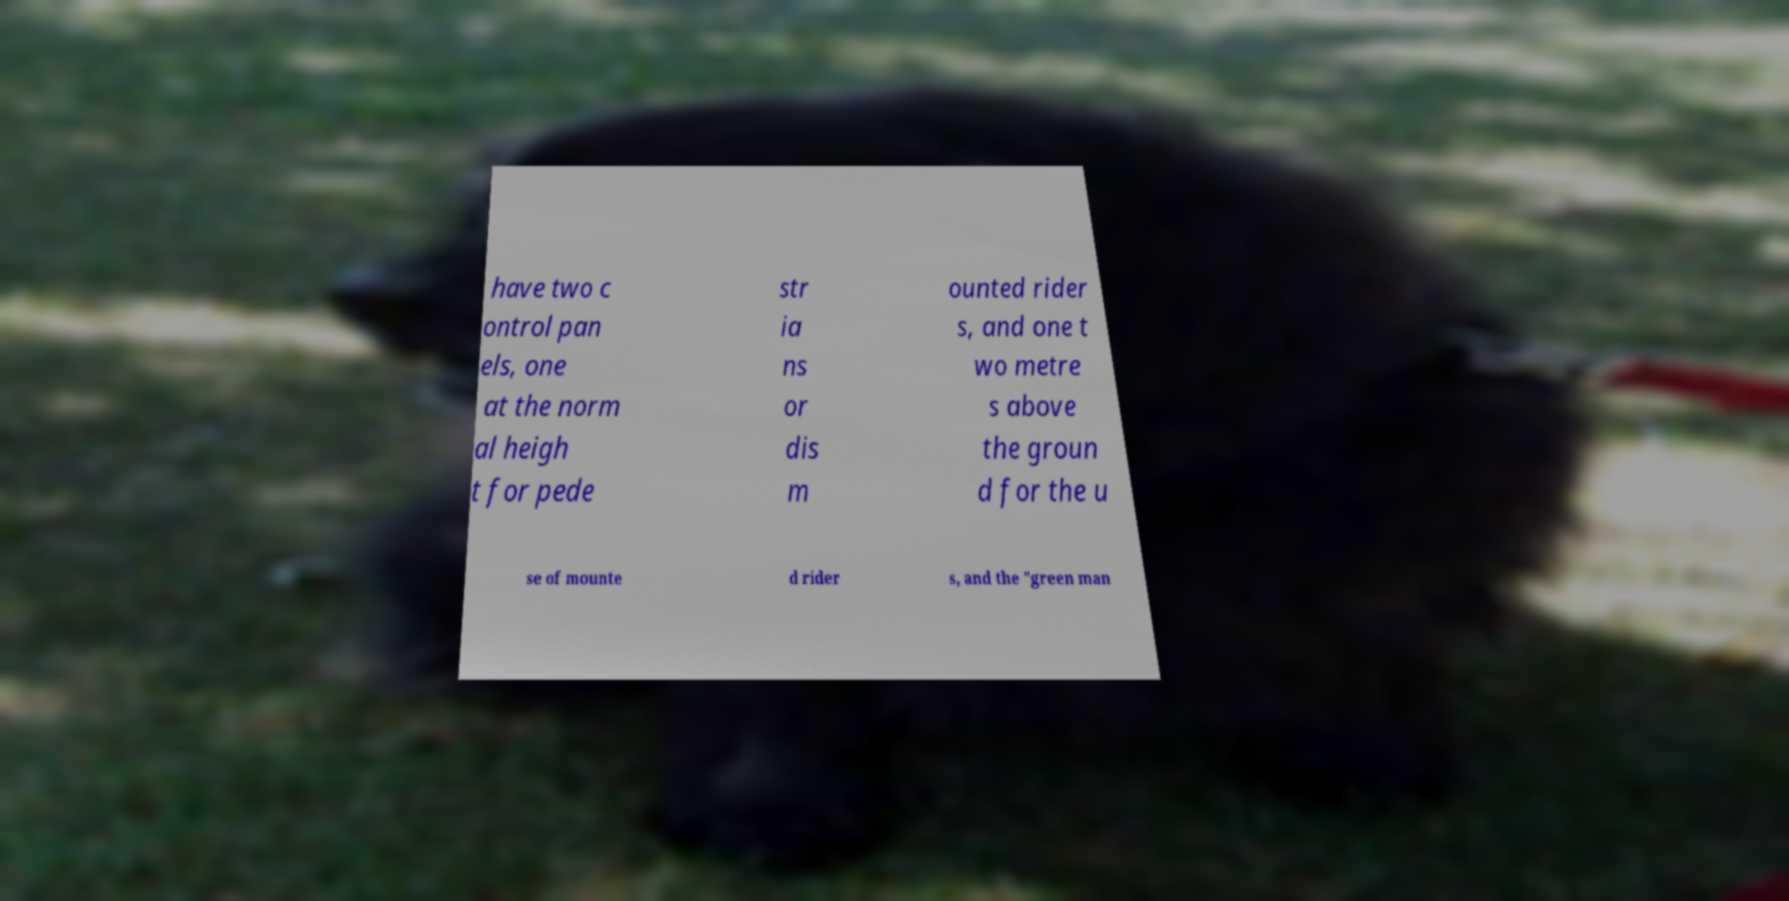Could you assist in decoding the text presented in this image and type it out clearly? have two c ontrol pan els, one at the norm al heigh t for pede str ia ns or dis m ounted rider s, and one t wo metre s above the groun d for the u se of mounte d rider s, and the "green man 